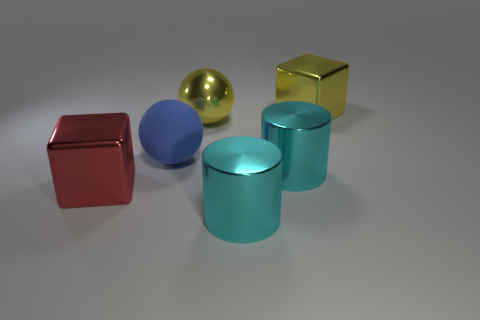Is there anything else that has the same material as the blue thing?
Offer a very short reply. No. Is the size of the metallic cube behind the blue matte thing the same as the cube in front of the big blue sphere?
Offer a terse response. Yes. Are there any cyan objects that have the same material as the yellow ball?
Give a very brief answer. Yes. What number of things are either cubes behind the red block or large red objects?
Provide a succinct answer. 2. Are the large yellow ball behind the large matte thing and the yellow block made of the same material?
Make the answer very short. Yes. Is the shape of the large red object the same as the large blue thing?
Your answer should be very brief. No. What number of large red shiny blocks are behind the big metal thing left of the big matte ball?
Give a very brief answer. 0. There is another object that is the same shape as the red thing; what is its material?
Offer a very short reply. Metal. There is a metal block in front of the yellow metallic cube; is its color the same as the rubber sphere?
Ensure brevity in your answer.  No. Is the big red block made of the same material as the cube behind the big yellow ball?
Provide a short and direct response. Yes. 